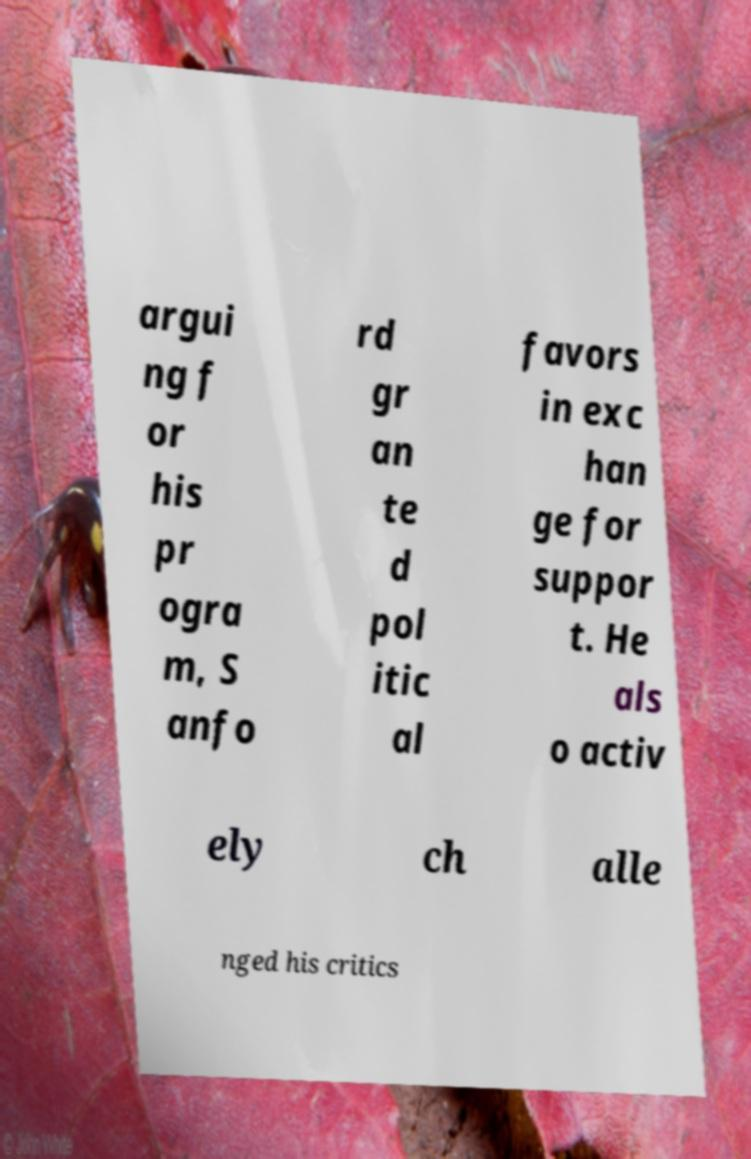Can you read and provide the text displayed in the image?This photo seems to have some interesting text. Can you extract and type it out for me? argui ng f or his pr ogra m, S anfo rd gr an te d pol itic al favors in exc han ge for suppor t. He als o activ ely ch alle nged his critics 